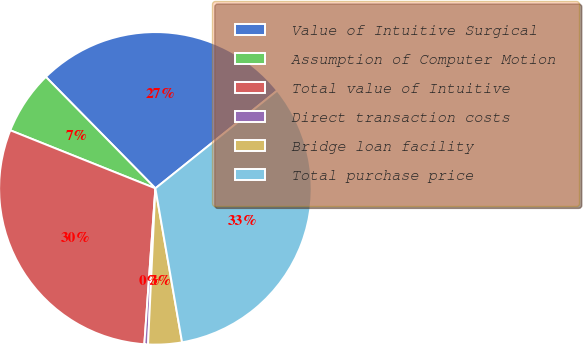Convert chart. <chart><loc_0><loc_0><loc_500><loc_500><pie_chart><fcel>Value of Intuitive Surgical<fcel>Assumption of Computer Motion<fcel>Total value of Intuitive<fcel>Direct transaction costs<fcel>Bridge loan facility<fcel>Total purchase price<nl><fcel>26.6%<fcel>6.58%<fcel>29.93%<fcel>0.38%<fcel>3.48%<fcel>33.03%<nl></chart> 